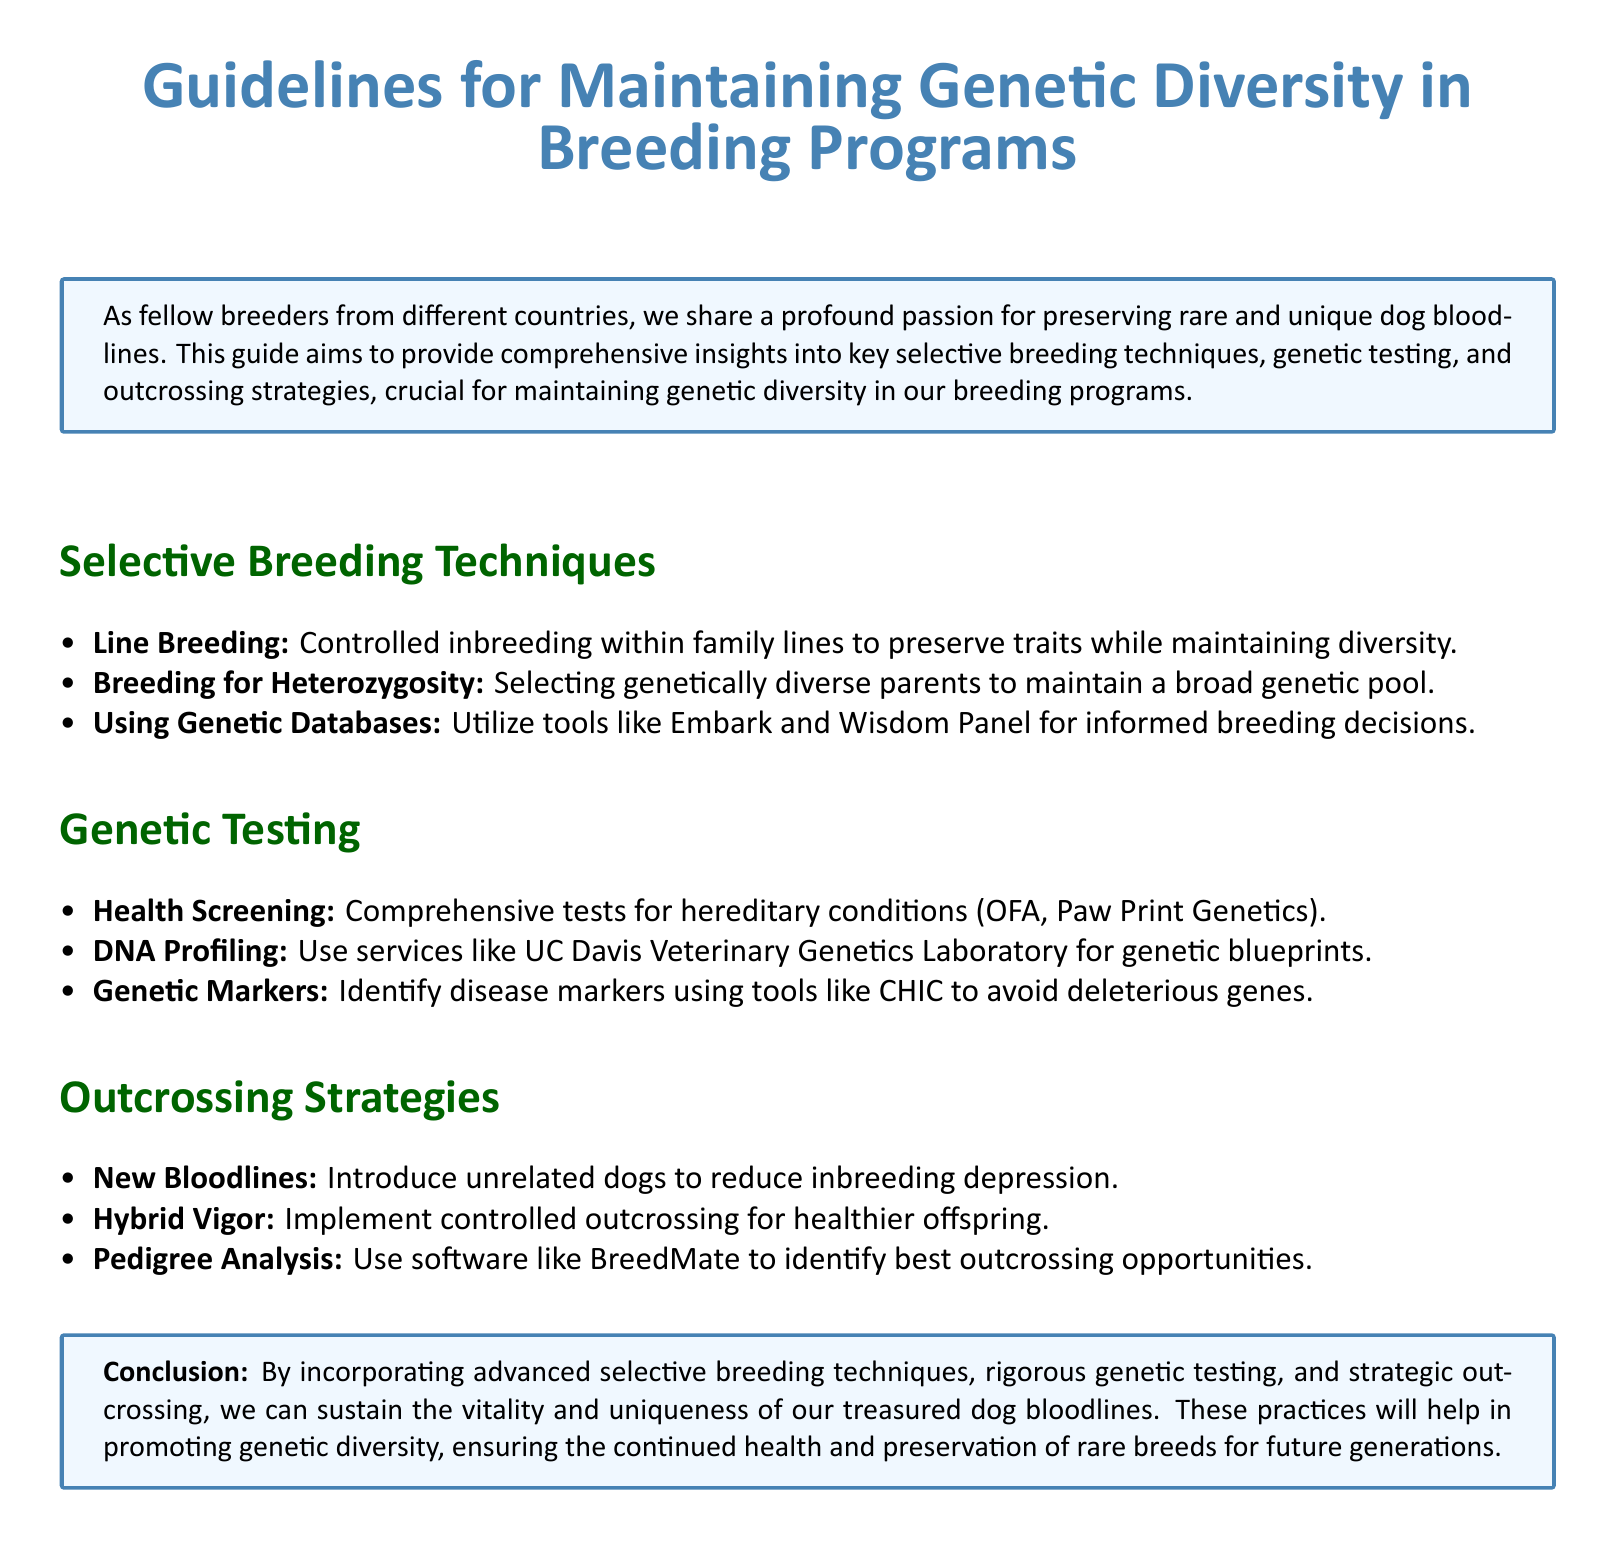What is the title of the document? The title is prominently displayed at the top of the document, indicating its main subject focus.
Answer: Guidelines for Maintaining Genetic Diversity in Breeding Programs What are the three main sections of the document? The sections are summarized in the outline, providing a clear structure of the content covered.
Answer: Selective Breeding Techniques, Genetic Testing, Outcrossing Strategies What is the purpose of genetic testing mentioned in the document? The document highlights the role of genetic testing in assessing health and identifying genetic conditions.
Answer: Health Screening What technique is used to introduce unrelated dogs? This technique is aimed at reducing the risk of inbreeding-related issues.
Answer: New Bloodlines Which tool is suggested for pedigree analysis? The document recommends specific software that assists in analyzing breeding options.
Answer: BreedMate What is the goal of breeding for heterozygosity? This breeding strategy is designed to enhance genetic variability among offspring.
Answer: Maintain a broad genetic pool Which service is mentioned for DNA profiling? The document includes a specific institution providing DNA profiling services to breeders.
Answer: UC Davis Veterinary Genetics Laboratory What is the effect of hybrid vigor in breeding programs? The document explains the beneficial outcome of this strategy on the health of offspring.
Answer: Healthier offspring 